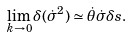Convert formula to latex. <formula><loc_0><loc_0><loc_500><loc_500>\lim _ { k \rightarrow 0 } \delta ( \dot { \sigma } ^ { 2 } ) \simeq \dot { \theta } \dot { \sigma } \delta s .</formula> 